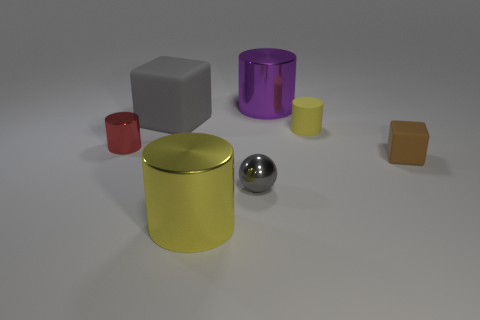The large object that is both behind the red metal cylinder and right of the gray cube is made of what material?
Your answer should be compact. Metal. Are there any tiny red metal objects that are in front of the large gray object behind the tiny cylinder left of the big purple metallic cylinder?
Ensure brevity in your answer.  Yes. Is there a brown matte cube of the same size as the yellow matte cylinder?
Your answer should be very brief. Yes. What size is the rubber block that is behind the tiny brown cube?
Keep it short and to the point. Large. There is a small metal thing that is on the right side of the block left of the yellow cylinder on the left side of the big purple cylinder; what color is it?
Provide a short and direct response. Gray. What is the color of the big metallic cylinder to the right of the yellow object that is left of the gray metal sphere?
Your response must be concise. Purple. Is the number of gray objects that are on the right side of the big cube greater than the number of red metallic objects that are behind the small red shiny cylinder?
Your answer should be very brief. Yes. Are the block in front of the small yellow cylinder and the large object that is on the left side of the yellow metallic object made of the same material?
Provide a short and direct response. Yes. There is a gray matte block; are there any yellow rubber things on the left side of it?
Offer a very short reply. No. What number of purple objects are either big objects or metal things?
Offer a terse response. 1. 